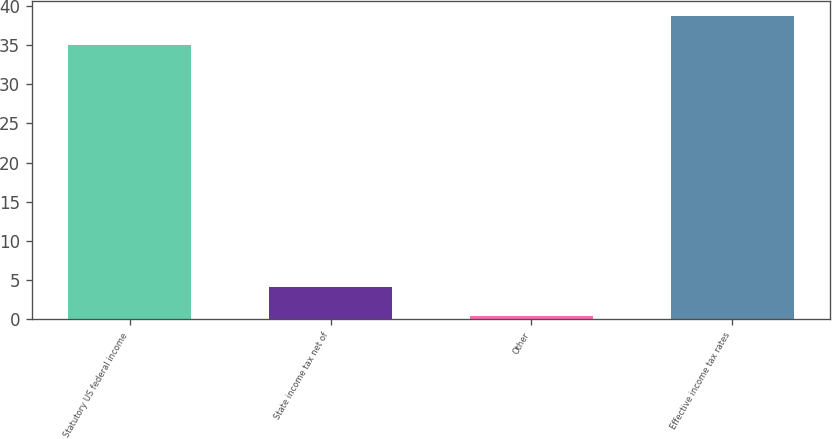Convert chart to OTSL. <chart><loc_0><loc_0><loc_500><loc_500><bar_chart><fcel>Statutory US federal income<fcel>State income tax net of<fcel>Other<fcel>Effective income tax rates<nl><fcel>35<fcel>4.17<fcel>0.4<fcel>38.77<nl></chart> 